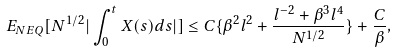Convert formula to latex. <formula><loc_0><loc_0><loc_500><loc_500>E _ { N E Q } [ N ^ { 1 / 2 } | \int _ { 0 } ^ { t } X ( s ) d s | ] \leq C \{ \beta ^ { 2 } l ^ { 2 } + \frac { l ^ { - 2 } + \beta ^ { 3 } l ^ { 4 } } { N ^ { 1 / 2 } } \} + \frac { C } { \beta } ,</formula> 